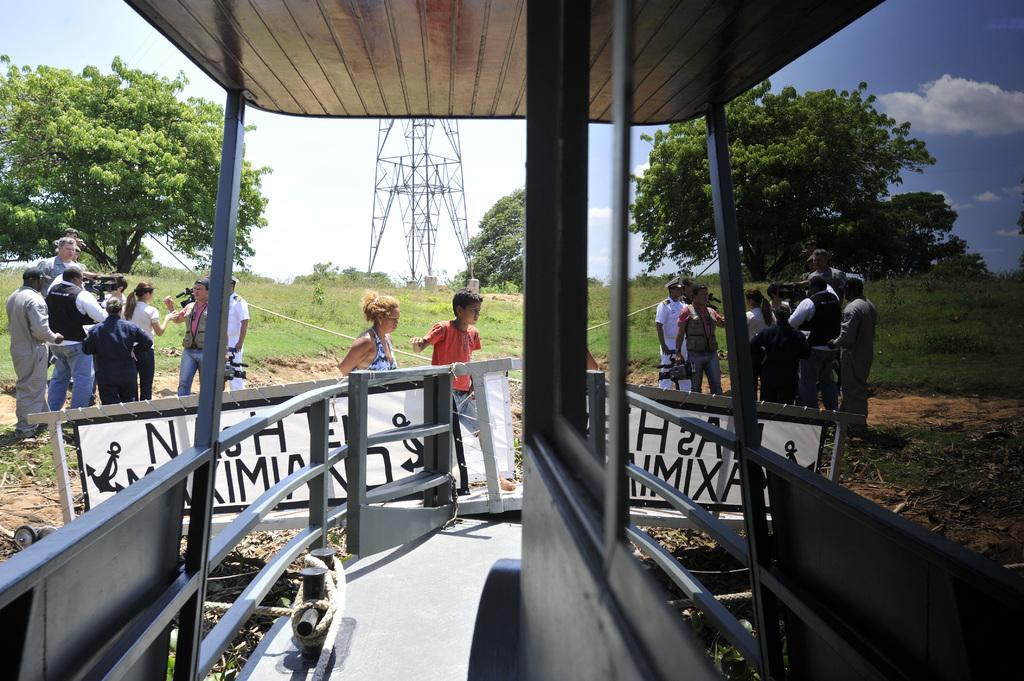Who or what is present in the image? There are people in the image. Where are the people located in the image? The people are standing on the left side of the image. What are the people holding in the image? The people are holding a video recording camera. What type of song is being played in the background of the image? There is no information about a song being played in the background of the image. 